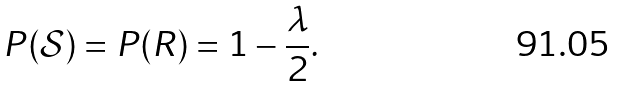<formula> <loc_0><loc_0><loc_500><loc_500>P ( \mathcal { S } ) = P ( R ) = 1 - \frac { \lambda } { 2 } .</formula> 